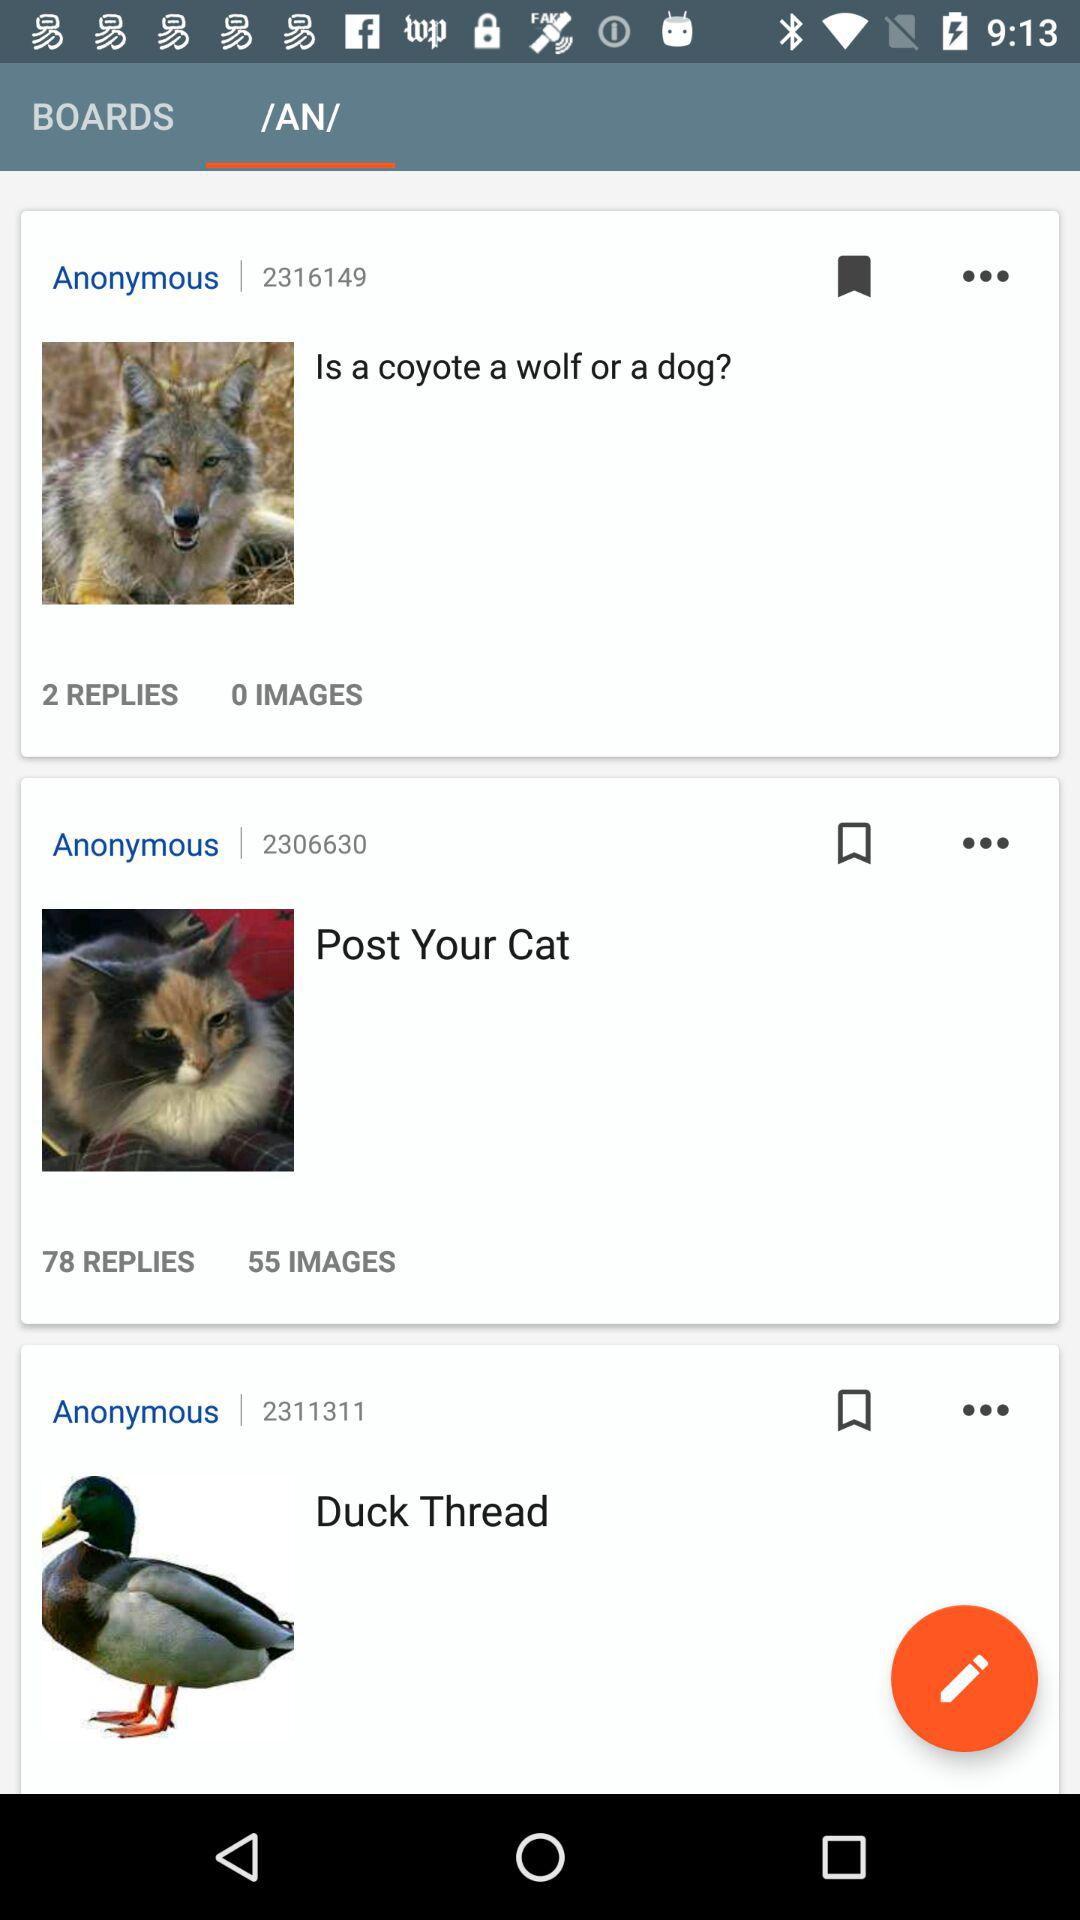How many people responded to the post "Post Your Cat"? The number of people who responded to the post "Post Your Cat" is 78. 